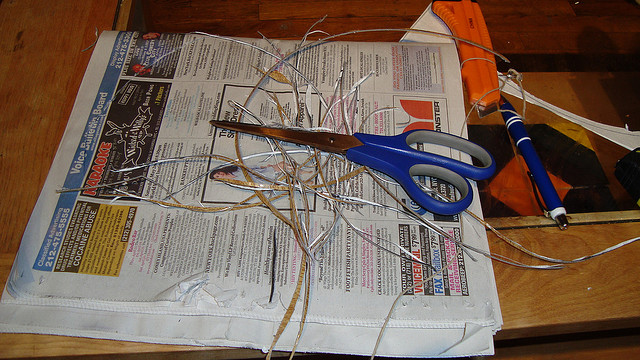<image>What kind of craft is being done? I am not sure what kind of craft is being done. It ranges from basket weaving, knitting, paper mache or even metal crafts. What kind of craft is being done? I don't know what kind of craft is being done. It can be basket weaving, paper mache, knitting or wrapping. 